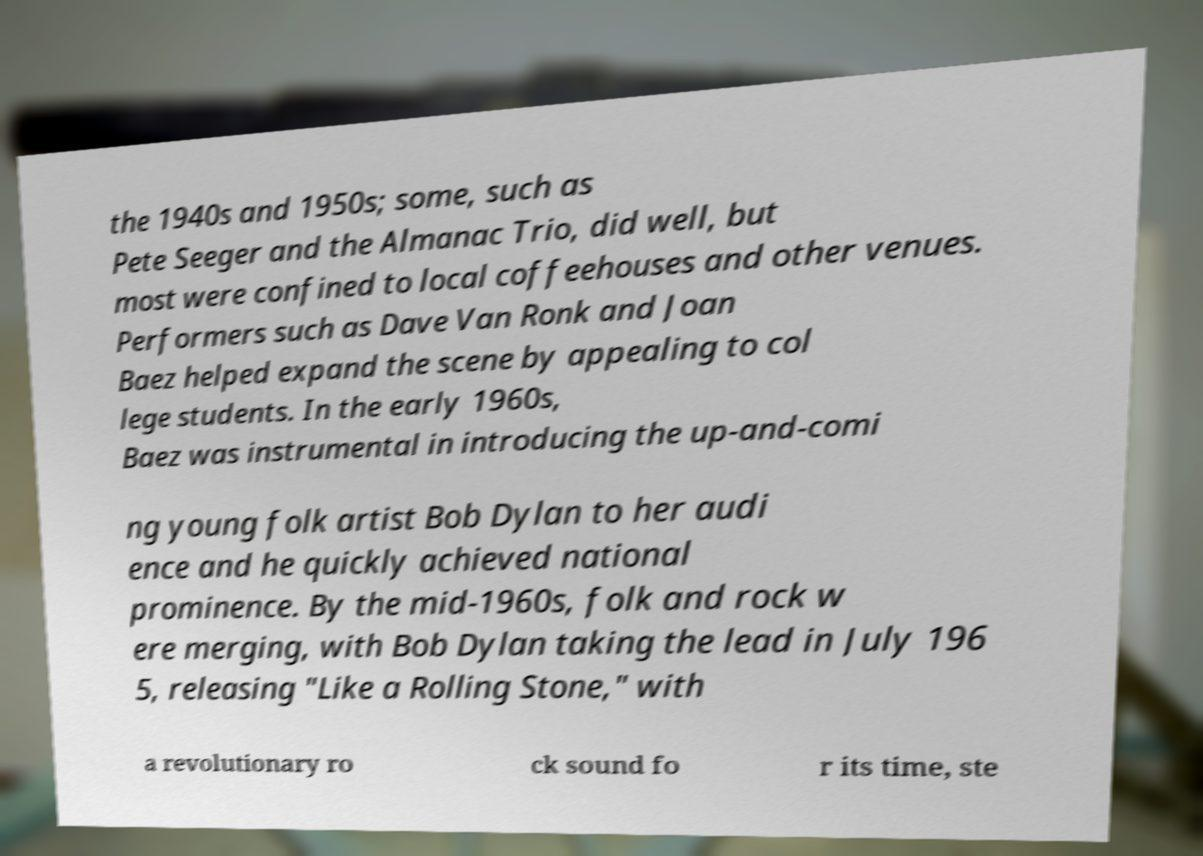Could you assist in decoding the text presented in this image and type it out clearly? the 1940s and 1950s; some, such as Pete Seeger and the Almanac Trio, did well, but most were confined to local coffeehouses and other venues. Performers such as Dave Van Ronk and Joan Baez helped expand the scene by appealing to col lege students. In the early 1960s, Baez was instrumental in introducing the up-and-comi ng young folk artist Bob Dylan to her audi ence and he quickly achieved national prominence. By the mid-1960s, folk and rock w ere merging, with Bob Dylan taking the lead in July 196 5, releasing "Like a Rolling Stone," with a revolutionary ro ck sound fo r its time, ste 